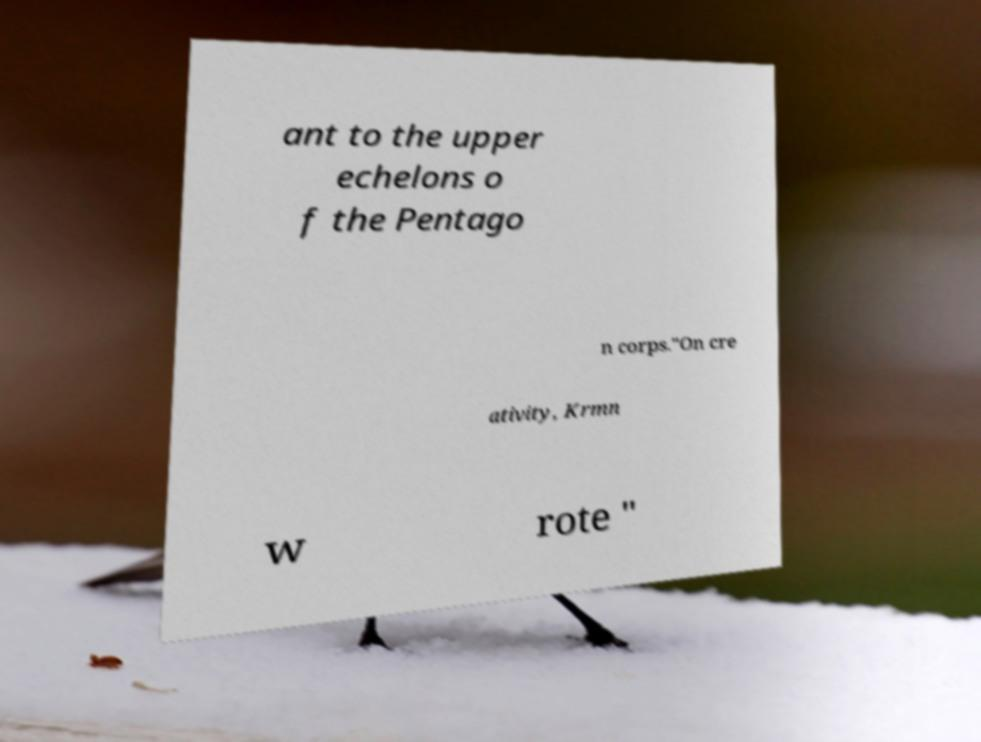Please read and relay the text visible in this image. What does it say? ant to the upper echelons o f the Pentago n corps."On cre ativity, Krmn w rote " 